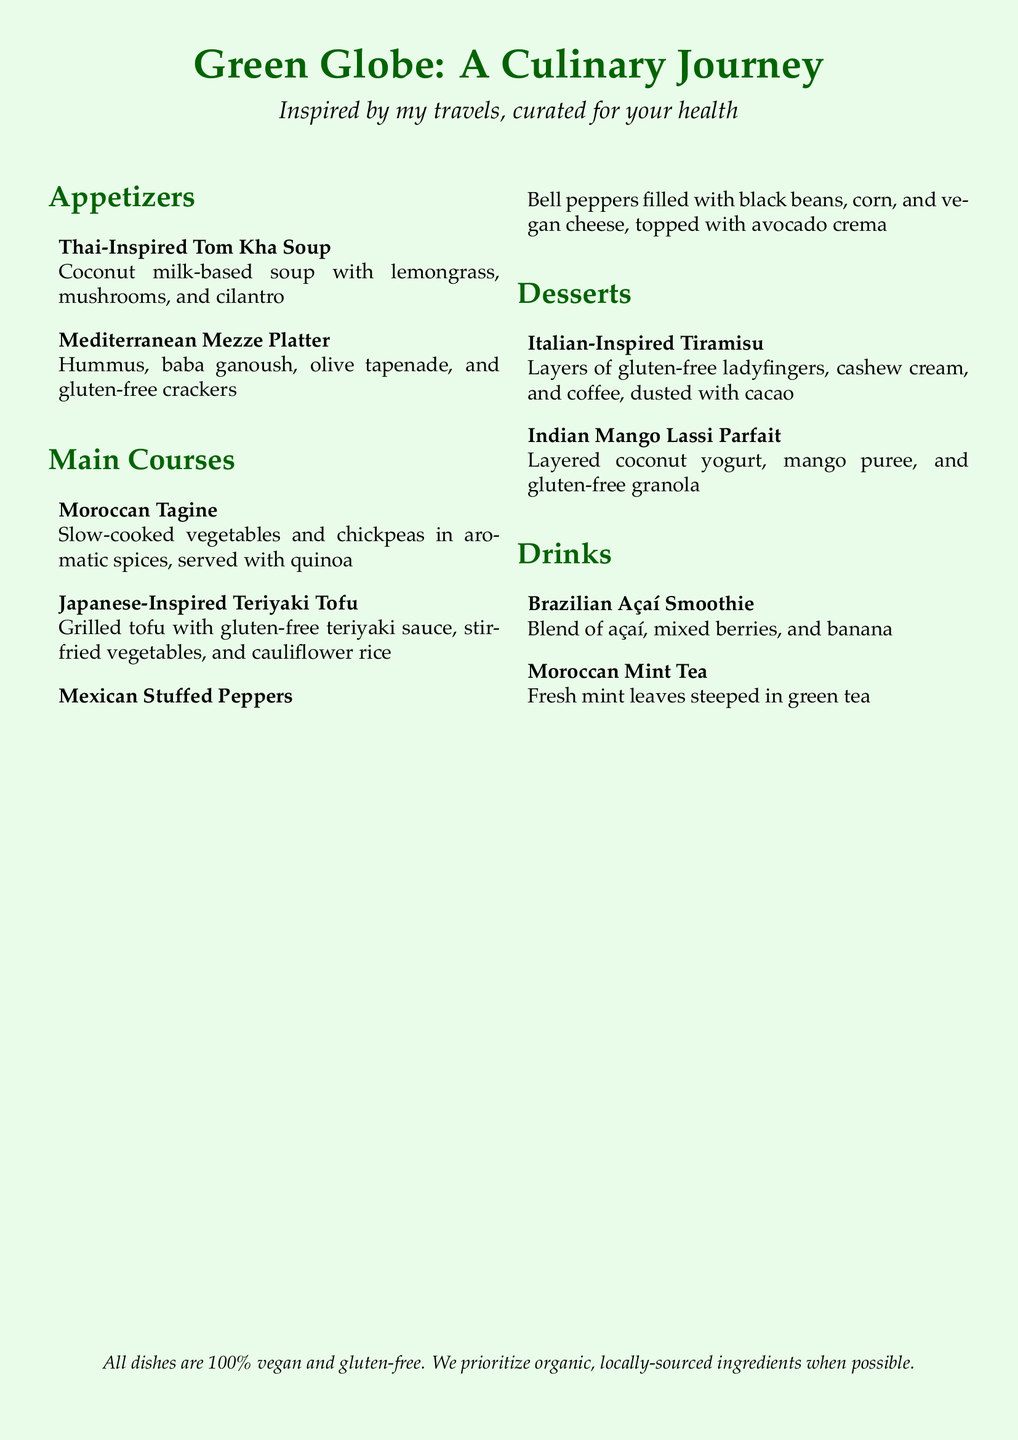what is the name of the menu? The name of the menu is presented at the top of the document, highlighting its theme.
Answer: Green Globe: A Culinary Journey how many appetizers are listed? The number of appetizers can be counted in the "Appetizers" section of the menu.
Answer: 2 what type of rice is served with the Japanese-Inspired Teriyaki Tofu? The type of rice served is mentioned in the description of the main course.
Answer: cauliflower rice which dessert features layers of gluten-free ladyfingers? The dessert name is specified in the "Desserts" section of the menu.
Answer: Italian-Inspired Tiramisu what key ingredient is used in the Mediterranean Mezze Platter? Key ingredients are outlined in the description of the appetizer.
Answer: hummus how many main courses are featured in the menu? The total number of main courses can be counted in the "Main Courses" section.
Answer: 3 what is the base of the Thai-Inspired Tom Kha Soup? The base ingredient is specified in the description of the soup.
Answer: coconut milk which drink includes fresh mint leaves? The drink is identified in the "Drinks" section.
Answer: Moroccan Mint Tea 